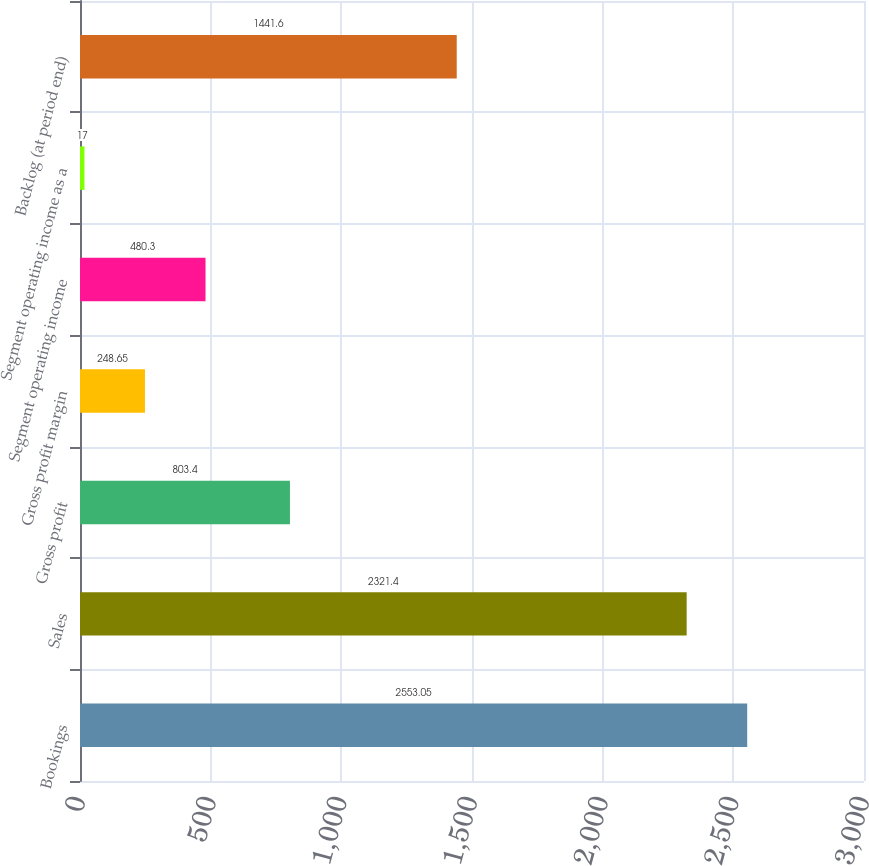Convert chart. <chart><loc_0><loc_0><loc_500><loc_500><bar_chart><fcel>Bookings<fcel>Sales<fcel>Gross profit<fcel>Gross profit margin<fcel>Segment operating income<fcel>Segment operating income as a<fcel>Backlog (at period end)<nl><fcel>2553.05<fcel>2321.4<fcel>803.4<fcel>248.65<fcel>480.3<fcel>17<fcel>1441.6<nl></chart> 